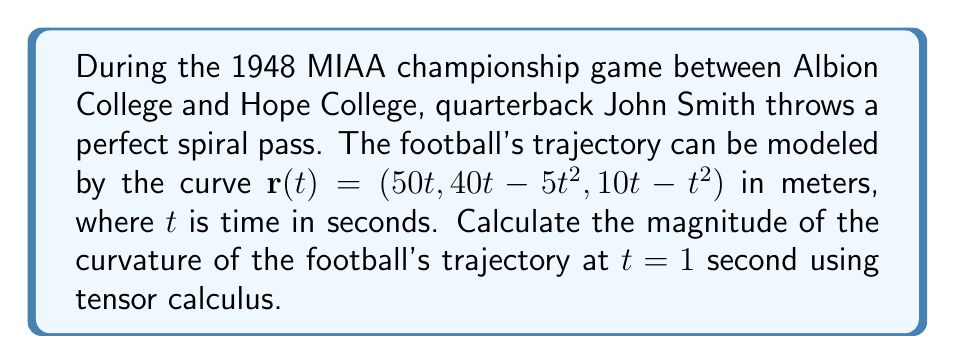Give your solution to this math problem. To calculate the curvature of the football's trajectory, we'll use the formula for the magnitude of curvature in tensor calculus:

$$\kappa = \frac{\sqrt{|\dot{\mathbf{r}} \times \ddot{\mathbf{r}}|^2}}{|\dot{\mathbf{r}}|^3}$$

Step 1: Calculate $\dot{\mathbf{r}}(t)$ (first derivative)
$$\dot{\mathbf{r}}(t) = (50, 40 - 10t, 10 - 2t)$$

Step 2: Calculate $\ddot{\mathbf{r}}(t)$ (second derivative)
$$\ddot{\mathbf{r}}(t) = (0, -10, -2)$$

Step 3: Evaluate $\dot{\mathbf{r}}(1)$ and $\ddot{\mathbf{r}}(1)$
$$\dot{\mathbf{r}}(1) = (50, 30, 8)$$
$$\ddot{\mathbf{r}}(1) = (0, -10, -2)$$

Step 4: Calculate $\dot{\mathbf{r}}(1) \times \ddot{\mathbf{r}}(1)$
$$\dot{\mathbf{r}}(1) \times \ddot{\mathbf{r}}(1) = \begin{vmatrix}
\mathbf{i} & \mathbf{j} & \mathbf{k} \\
50 & 30 & 8 \\
0 & -10 & -2
\end{vmatrix} = (-140, -100, -500)$$

Step 5: Calculate $|\dot{\mathbf{r}}(1) \times \ddot{\mathbf{r}}(1)|^2$
$$|\dot{\mathbf{r}}(1) \times \ddot{\mathbf{r}}(1)|^2 = (-140)^2 + (-100)^2 + (-500)^2 = 289,400$$

Step 6: Calculate $|\dot{\mathbf{r}}(1)|^3$
$$|\dot{\mathbf{r}}(1)|^3 = (50^2 + 30^2 + 8^2)^{3/2} = (3,364)^{3/2} \approx 195,605.54$$

Step 7: Apply the curvature formula
$$\kappa = \frac{\sqrt{289,400}}{195,605.54} \approx 0.0275 \text{ m}^{-1}$$
Answer: $0.0275 \text{ m}^{-1}$ 